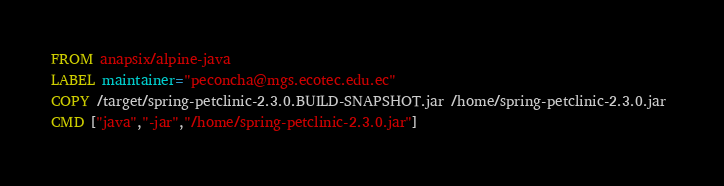<code> <loc_0><loc_0><loc_500><loc_500><_Dockerfile_>FROM anapsix/alpine-java 
LABEL maintainer="peconcha@mgs.ecotec.edu.ec" 
COPY /target/spring-petclinic-2.3.0.BUILD-SNAPSHOT.jar /home/spring-petclinic-2.3.0.jar 
CMD ["java","-jar","/home/spring-petclinic-2.3.0.jar"]
</code> 